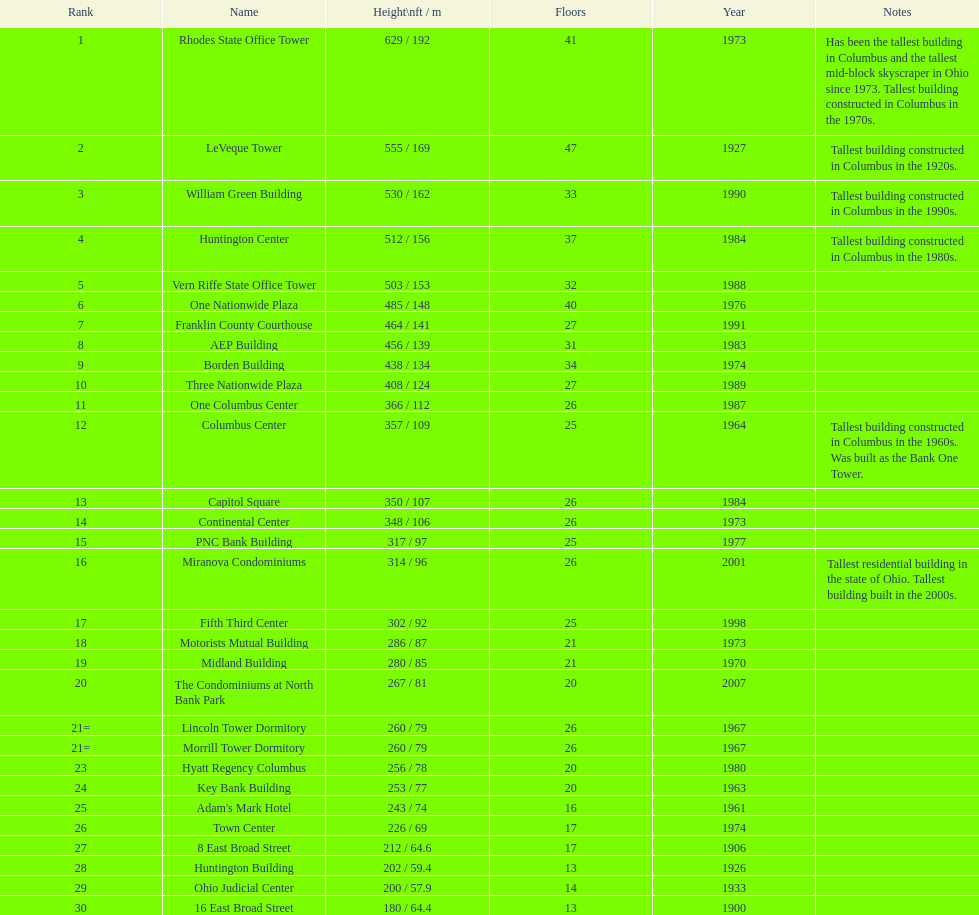What is the most elevated edifice in columbus? Rhodes State Office Tower. 